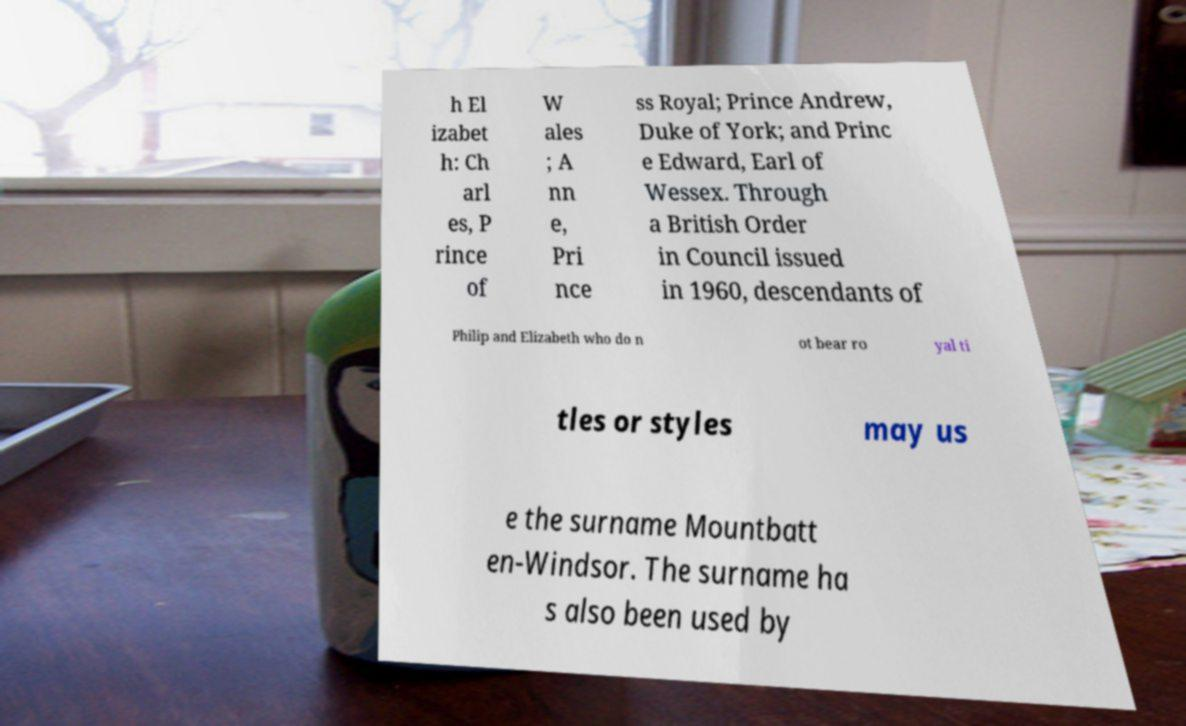Please read and relay the text visible in this image. What does it say? h El izabet h: Ch arl es, P rince of W ales ; A nn e, Pri nce ss Royal; Prince Andrew, Duke of York; and Princ e Edward, Earl of Wessex. Through a British Order in Council issued in 1960, descendants of Philip and Elizabeth who do n ot bear ro yal ti tles or styles may us e the surname Mountbatt en-Windsor. The surname ha s also been used by 